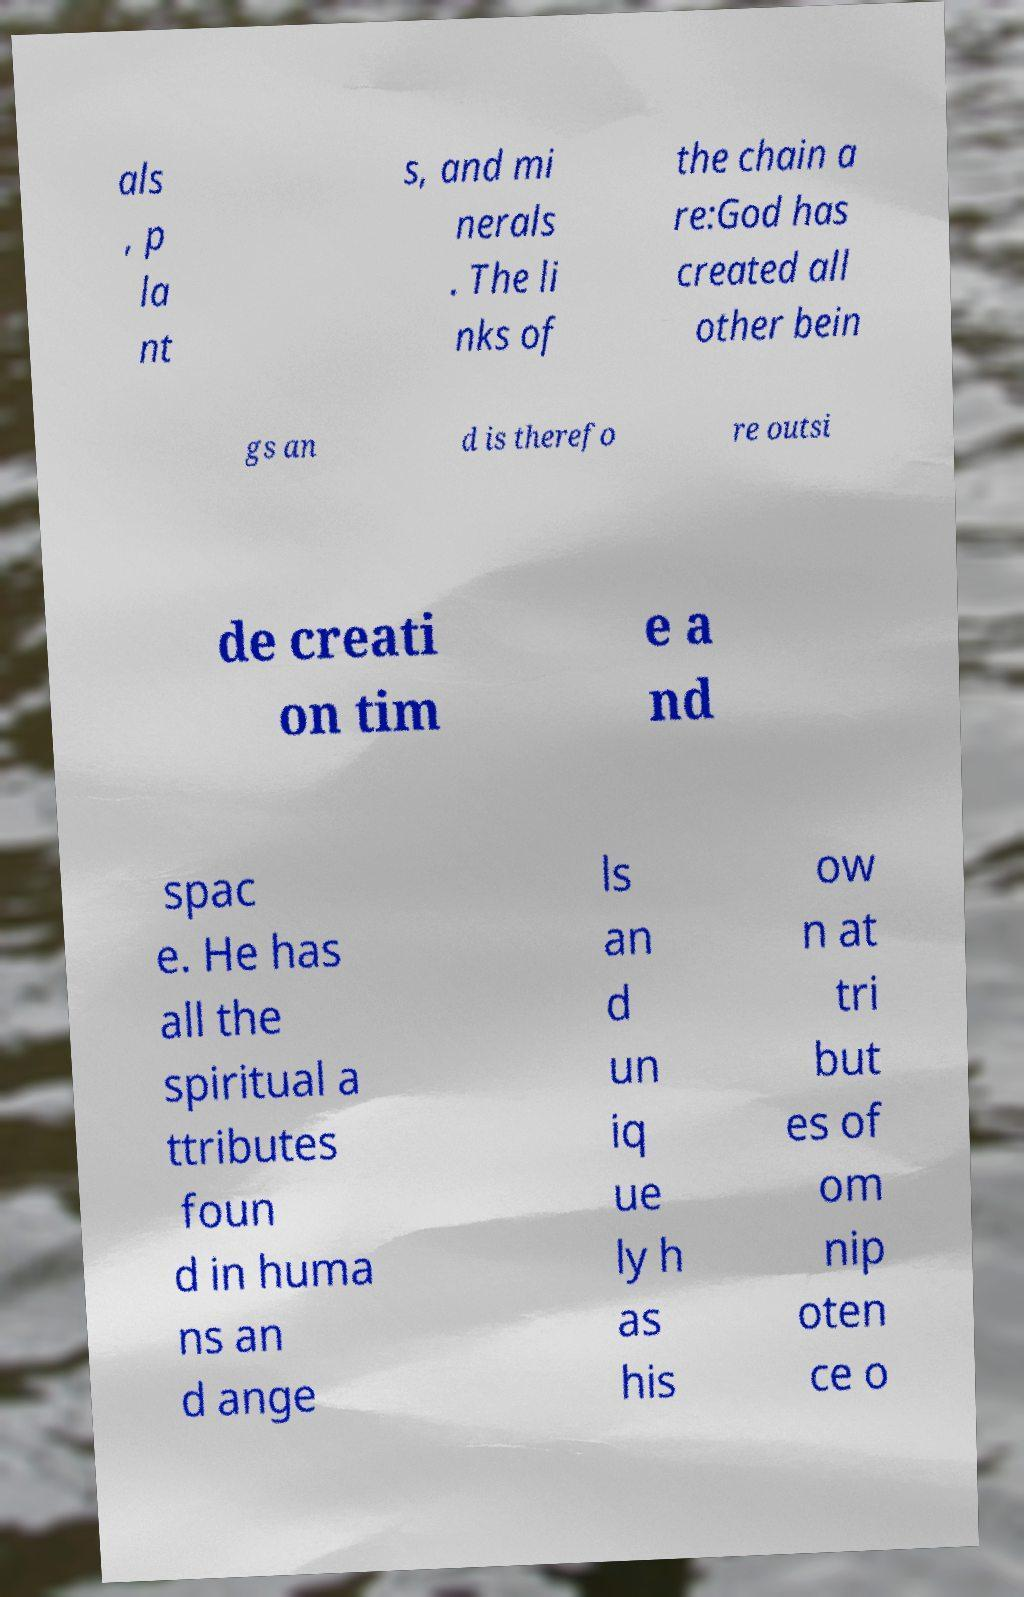Please read and relay the text visible in this image. What does it say? als , p la nt s, and mi nerals . The li nks of the chain a re:God has created all other bein gs an d is therefo re outsi de creati on tim e a nd spac e. He has all the spiritual a ttributes foun d in huma ns an d ange ls an d un iq ue ly h as his ow n at tri but es of om nip oten ce o 